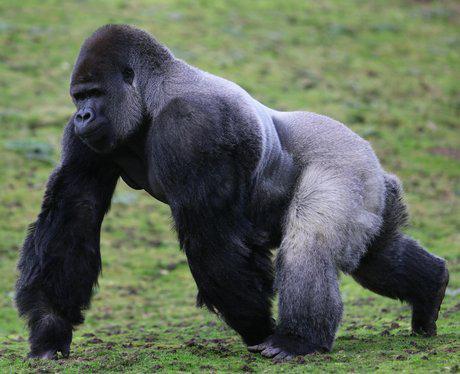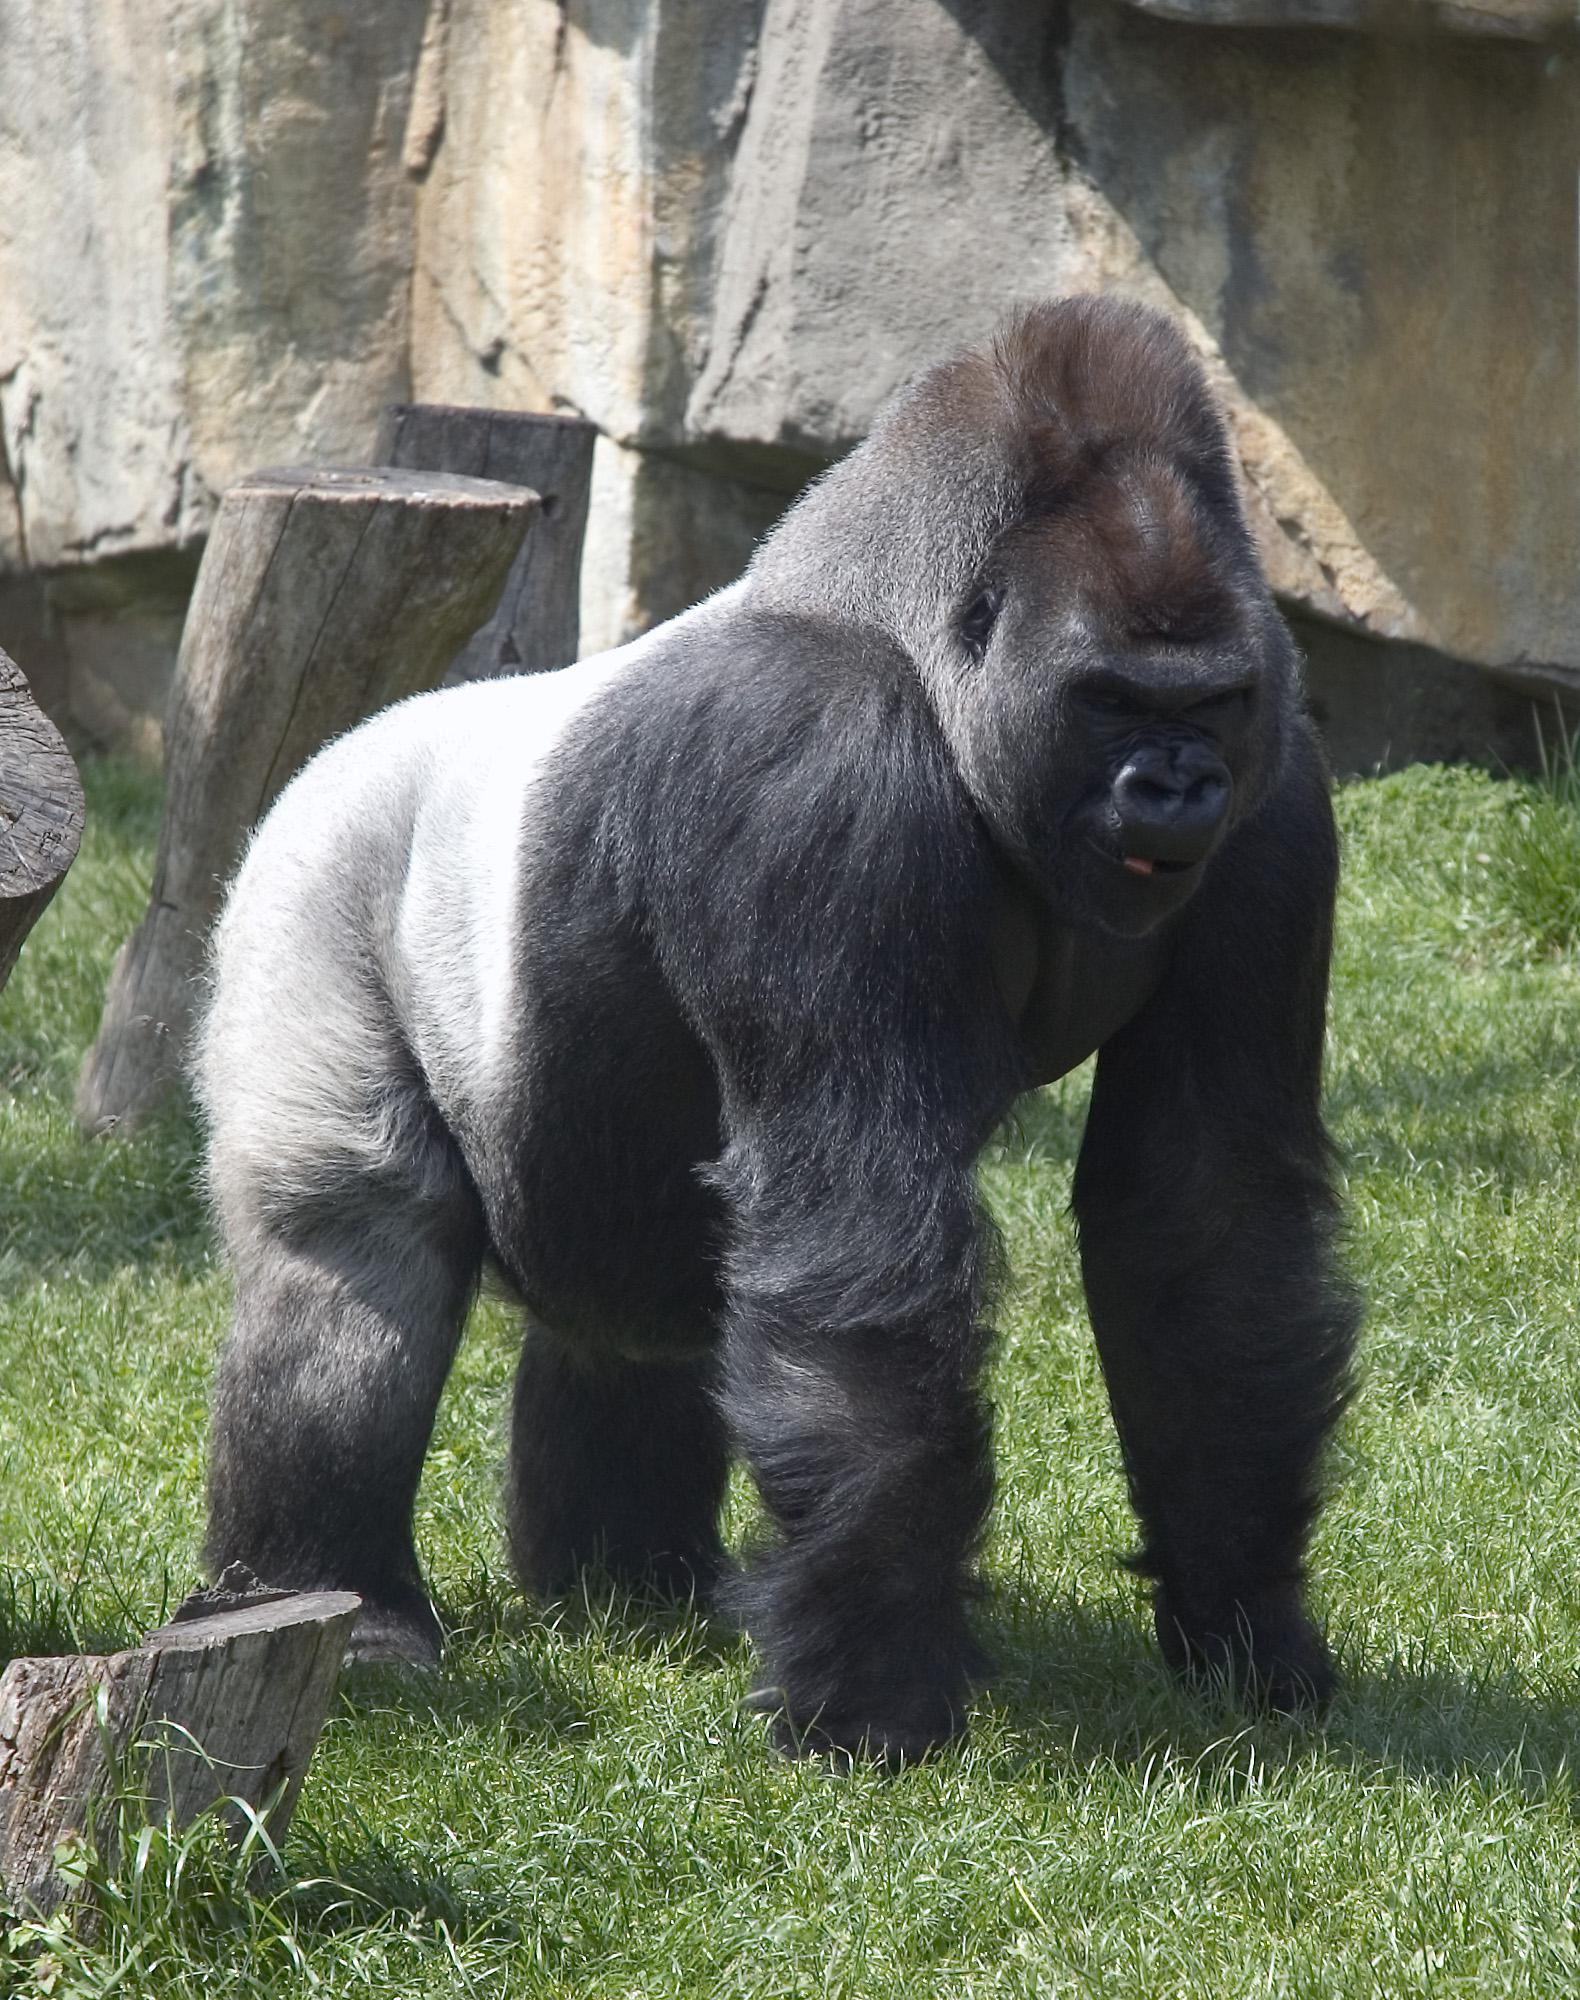The first image is the image on the left, the second image is the image on the right. Analyze the images presented: Is the assertion "There are two gorillas total." valid? Answer yes or no. Yes. The first image is the image on the left, the second image is the image on the right. For the images shown, is this caption "All of the images only contain one gorilla." true? Answer yes or no. Yes. 